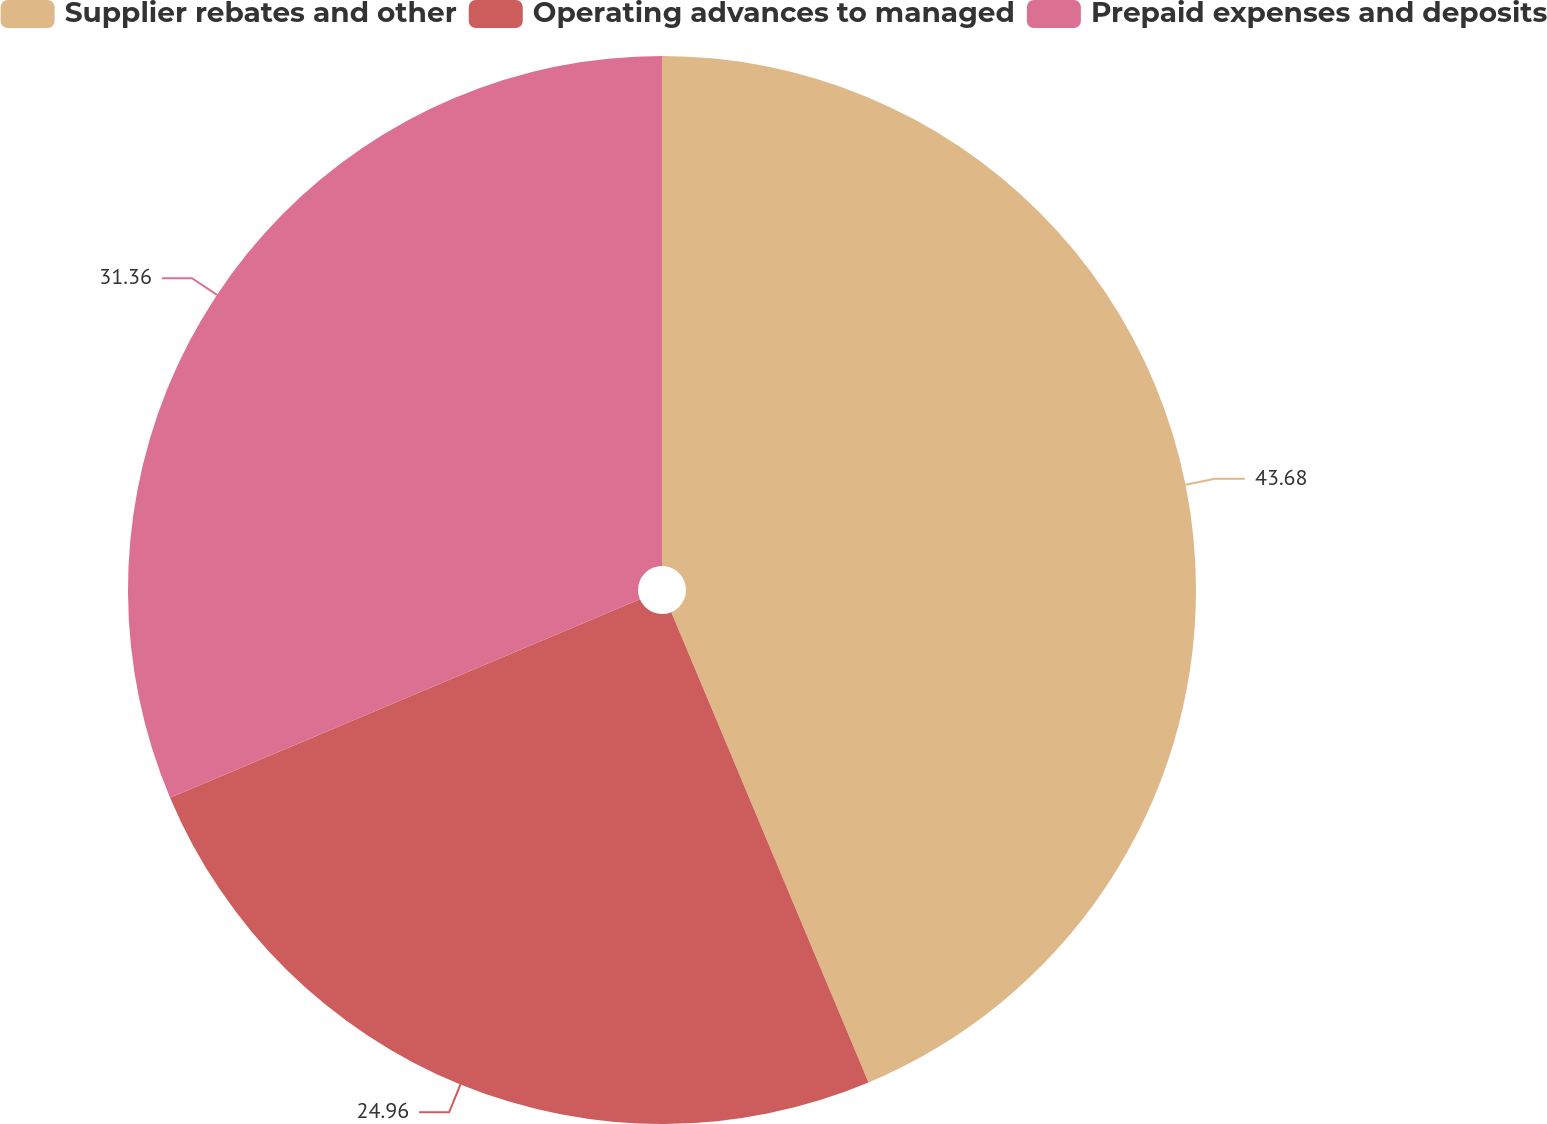<chart> <loc_0><loc_0><loc_500><loc_500><pie_chart><fcel>Supplier rebates and other<fcel>Operating advances to managed<fcel>Prepaid expenses and deposits<nl><fcel>43.68%<fcel>24.96%<fcel>31.36%<nl></chart> 